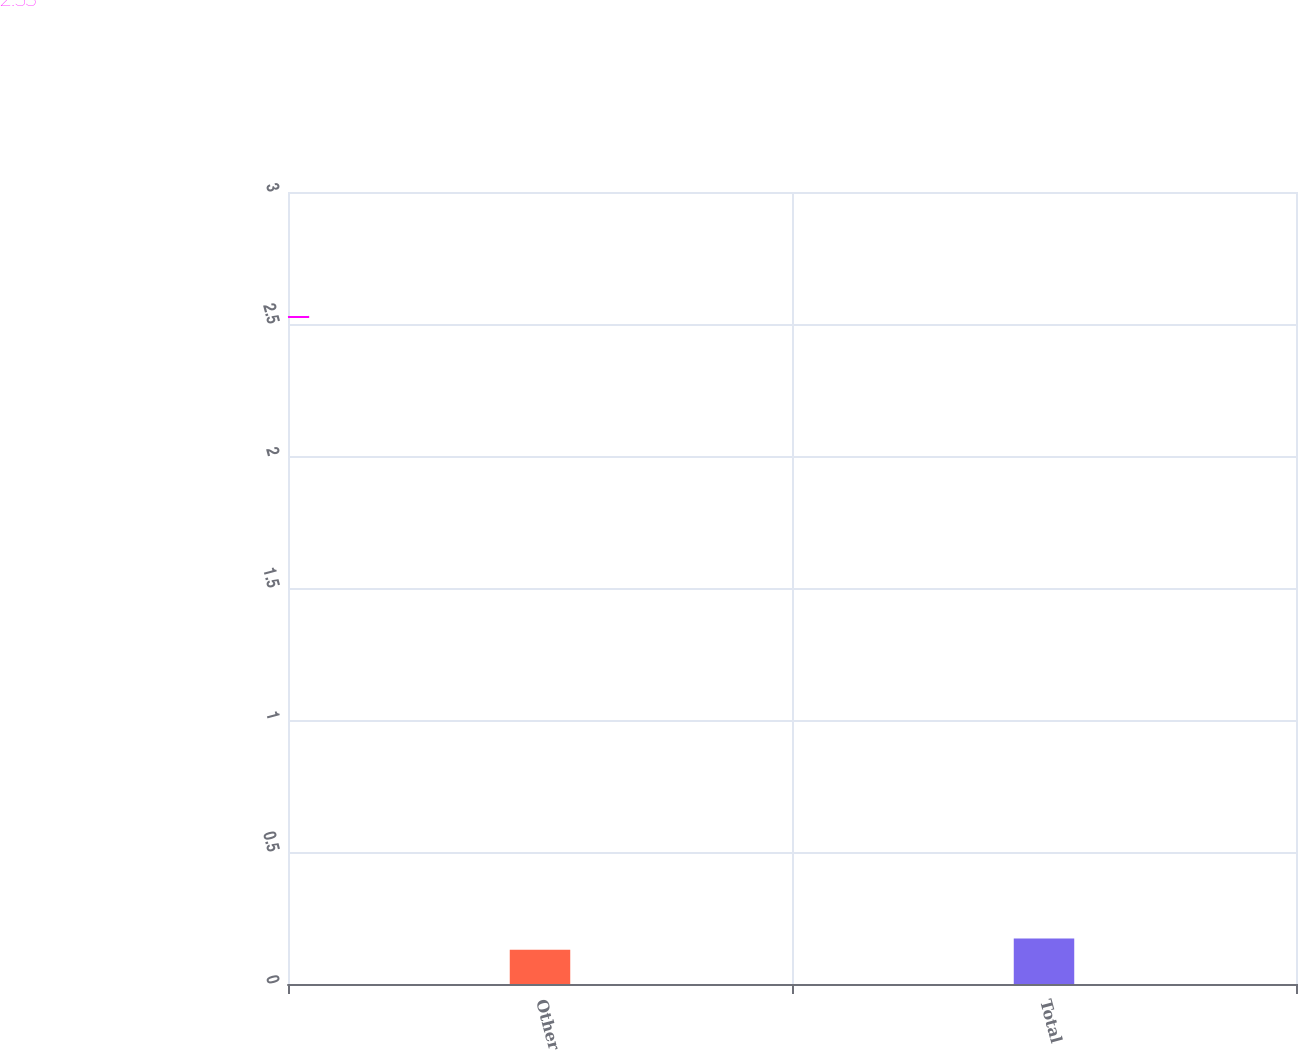Convert chart. <chart><loc_0><loc_0><loc_500><loc_500><bar_chart><fcel>Other<fcel>Total<nl><fcel>2.1<fcel>2.8<nl></chart> 